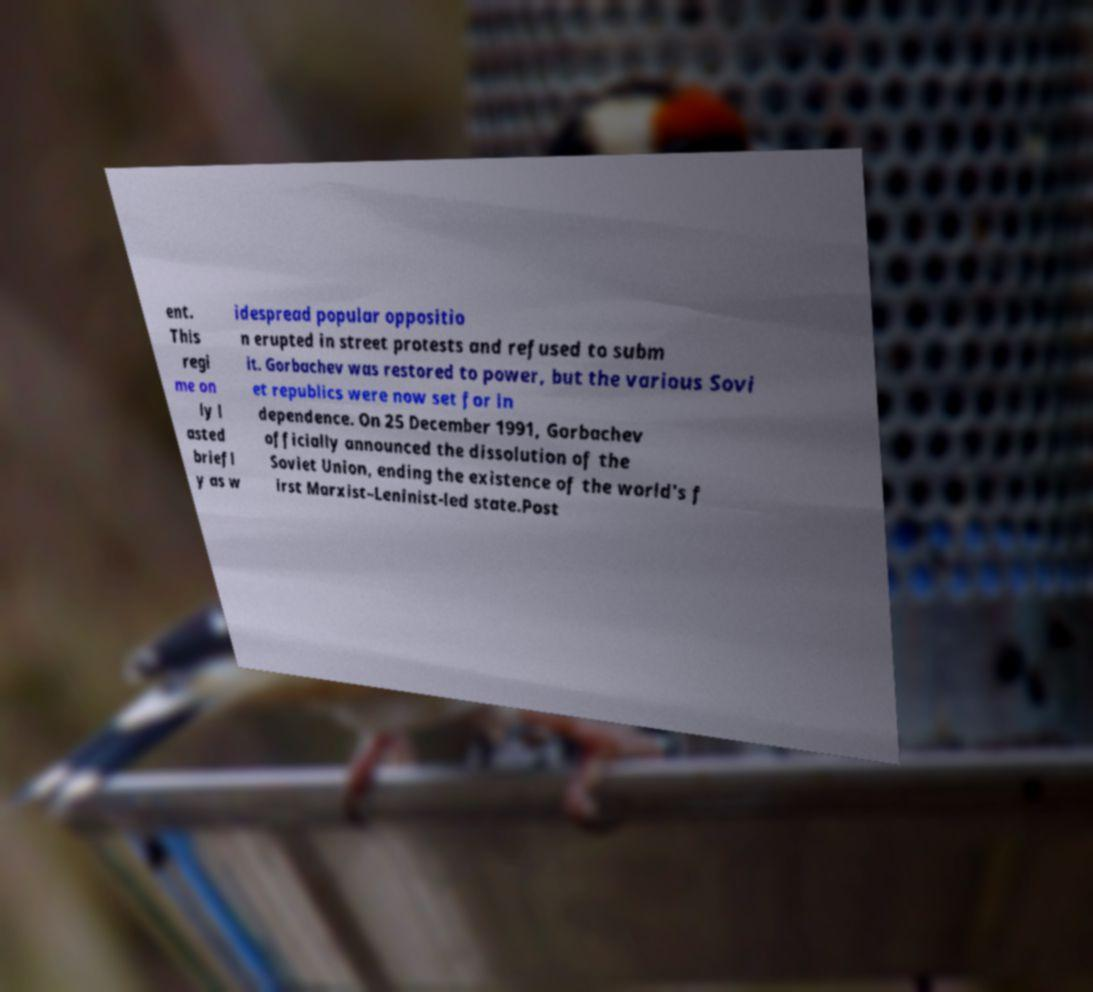Could you extract and type out the text from this image? ent. This regi me on ly l asted briefl y as w idespread popular oppositio n erupted in street protests and refused to subm it. Gorbachev was restored to power, but the various Sovi et republics were now set for in dependence. On 25 December 1991, Gorbachev officially announced the dissolution of the Soviet Union, ending the existence of the world's f irst Marxist–Leninist-led state.Post 